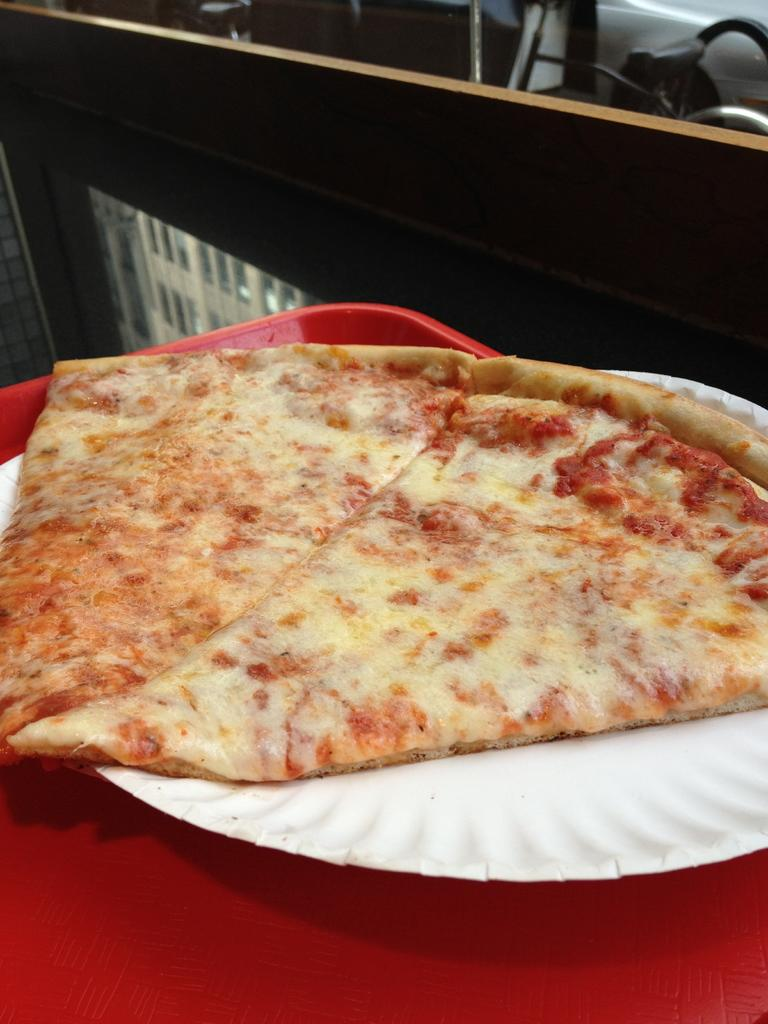What color is the tray in the image? The tray in the image is red. What is on the tray? There is a plate on the tray. What is on the plate? There is a pizza on the plate. What can be seen in the background of the image? There is a tree in the background of the image, and a chair is behind the tree. Are there any other objects visible in the background? Yes, there are other objects visible in the background. How many squirrels are sitting on the pizza in the image? There are no squirrels present in the image, and therefore none are sitting on the pizza. Is there a person in the image hosting a feast? There is no person hosting a feast in the image; it only shows a pizza on a plate. 